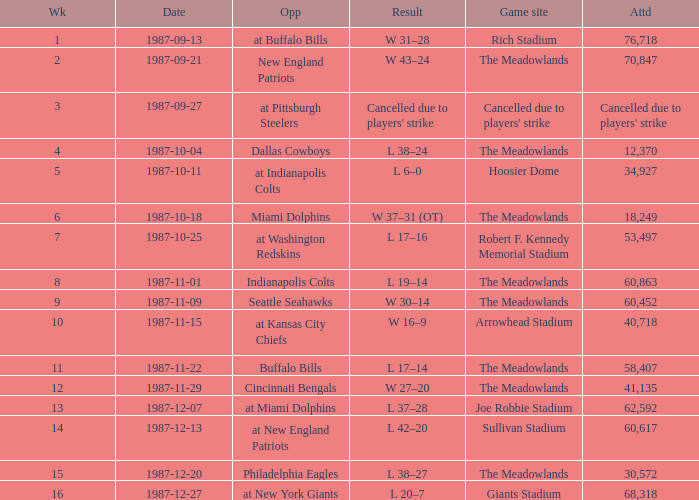Who did the Jets play in their pre-week 9 game at the Robert F. Kennedy memorial stadium? At washington redskins. 